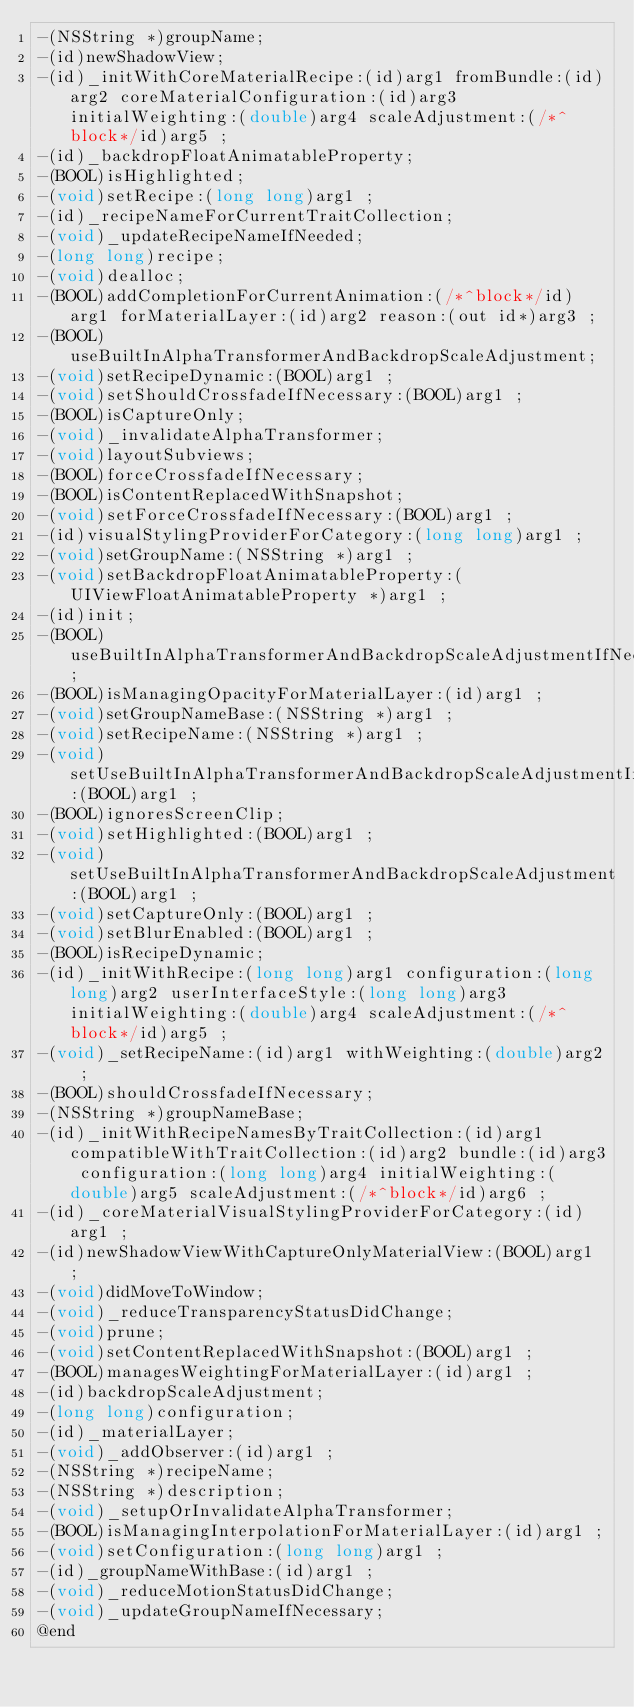<code> <loc_0><loc_0><loc_500><loc_500><_C_>-(NSString *)groupName;
-(id)newShadowView;
-(id)_initWithCoreMaterialRecipe:(id)arg1 fromBundle:(id)arg2 coreMaterialConfiguration:(id)arg3 initialWeighting:(double)arg4 scaleAdjustment:(/*^block*/id)arg5 ;
-(id)_backdropFloatAnimatableProperty;
-(BOOL)isHighlighted;
-(void)setRecipe:(long long)arg1 ;
-(id)_recipeNameForCurrentTraitCollection;
-(void)_updateRecipeNameIfNeeded;
-(long long)recipe;
-(void)dealloc;
-(BOOL)addCompletionForCurrentAnimation:(/*^block*/id)arg1 forMaterialLayer:(id)arg2 reason:(out id*)arg3 ;
-(BOOL)useBuiltInAlphaTransformerAndBackdropScaleAdjustment;
-(void)setRecipeDynamic:(BOOL)arg1 ;
-(void)setShouldCrossfadeIfNecessary:(BOOL)arg1 ;
-(BOOL)isCaptureOnly;
-(void)_invalidateAlphaTransformer;
-(void)layoutSubviews;
-(BOOL)forceCrossfadeIfNecessary;
-(BOOL)isContentReplacedWithSnapshot;
-(void)setForceCrossfadeIfNecessary:(BOOL)arg1 ;
-(id)visualStylingProviderForCategory:(long long)arg1 ;
-(void)setGroupName:(NSString *)arg1 ;
-(void)setBackdropFloatAnimatableProperty:(UIViewFloatAnimatableProperty *)arg1 ;
-(id)init;
-(BOOL)useBuiltInAlphaTransformerAndBackdropScaleAdjustmentIfNecessary;
-(BOOL)isManagingOpacityForMaterialLayer:(id)arg1 ;
-(void)setGroupNameBase:(NSString *)arg1 ;
-(void)setRecipeName:(NSString *)arg1 ;
-(void)setUseBuiltInAlphaTransformerAndBackdropScaleAdjustmentIfNecessary:(BOOL)arg1 ;
-(BOOL)ignoresScreenClip;
-(void)setHighlighted:(BOOL)arg1 ;
-(void)setUseBuiltInAlphaTransformerAndBackdropScaleAdjustment:(BOOL)arg1 ;
-(void)setCaptureOnly:(BOOL)arg1 ;
-(void)setBlurEnabled:(BOOL)arg1 ;
-(BOOL)isRecipeDynamic;
-(id)_initWithRecipe:(long long)arg1 configuration:(long long)arg2 userInterfaceStyle:(long long)arg3 initialWeighting:(double)arg4 scaleAdjustment:(/*^block*/id)arg5 ;
-(void)_setRecipeName:(id)arg1 withWeighting:(double)arg2 ;
-(BOOL)shouldCrossfadeIfNecessary;
-(NSString *)groupNameBase;
-(id)_initWithRecipeNamesByTraitCollection:(id)arg1 compatibleWithTraitCollection:(id)arg2 bundle:(id)arg3 configuration:(long long)arg4 initialWeighting:(double)arg5 scaleAdjustment:(/*^block*/id)arg6 ;
-(id)_coreMaterialVisualStylingProviderForCategory:(id)arg1 ;
-(id)newShadowViewWithCaptureOnlyMaterialView:(BOOL)arg1 ;
-(void)didMoveToWindow;
-(void)_reduceTransparencyStatusDidChange;
-(void)prune;
-(void)setContentReplacedWithSnapshot:(BOOL)arg1 ;
-(BOOL)managesWeightingForMaterialLayer:(id)arg1 ;
-(id)backdropScaleAdjustment;
-(long long)configuration;
-(id)_materialLayer;
-(void)_addObserver:(id)arg1 ;
-(NSString *)recipeName;
-(NSString *)description;
-(void)_setupOrInvalidateAlphaTransformer;
-(BOOL)isManagingInterpolationForMaterialLayer:(id)arg1 ;
-(void)setConfiguration:(long long)arg1 ;
-(id)_groupNameWithBase:(id)arg1 ;
-(void)_reduceMotionStatusDidChange;
-(void)_updateGroupNameIfNecessary;
@end

</code> 